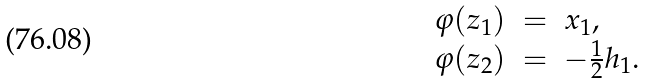Convert formula to latex. <formula><loc_0><loc_0><loc_500><loc_500>\begin{array} { l l l l l l } \varphi ( z _ { 1 } ) & = & x _ { 1 } , \\ \varphi ( z _ { 2 } ) & = & - \frac { 1 } { 2 } h _ { 1 } . \end{array}</formula> 